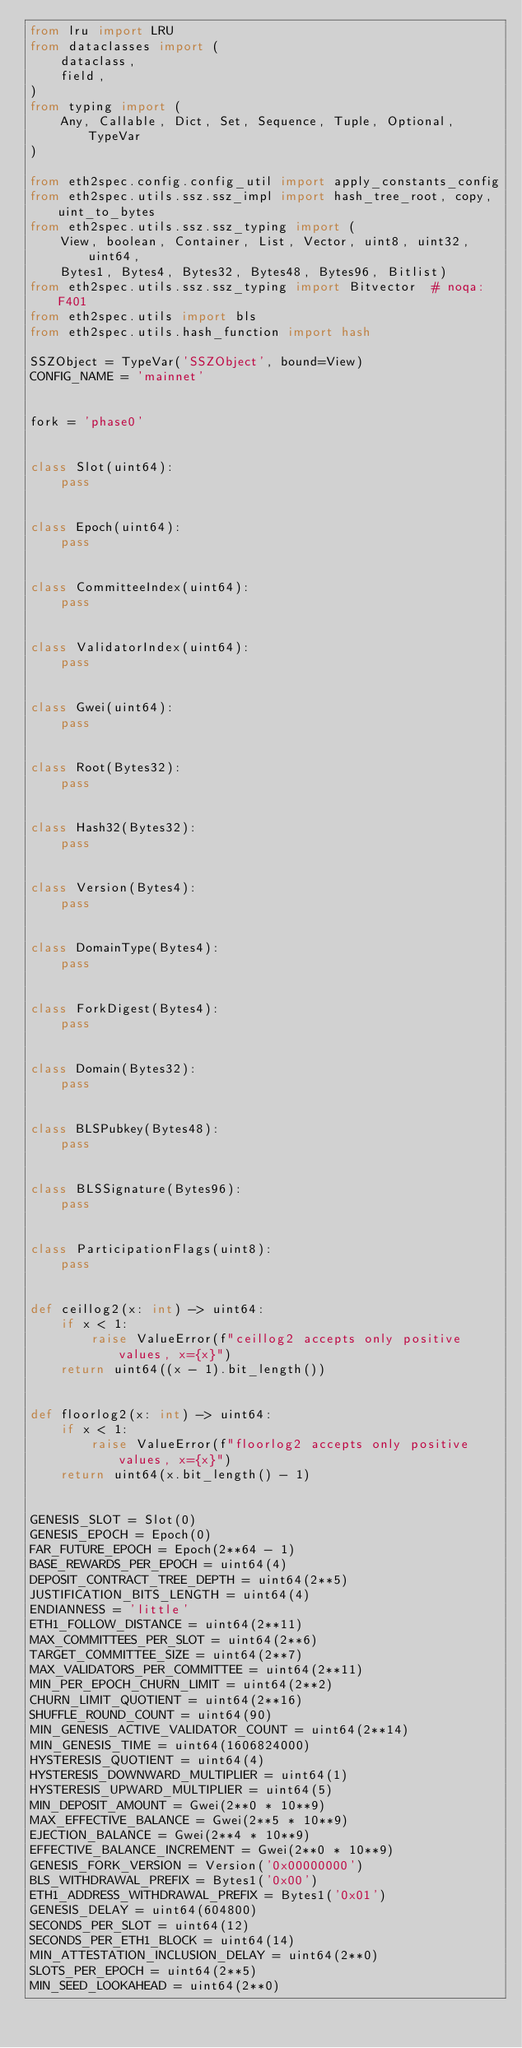Convert code to text. <code><loc_0><loc_0><loc_500><loc_500><_Python_>from lru import LRU
from dataclasses import (
    dataclass,
    field,
)
from typing import (
    Any, Callable, Dict, Set, Sequence, Tuple, Optional, TypeVar
)

from eth2spec.config.config_util import apply_constants_config
from eth2spec.utils.ssz.ssz_impl import hash_tree_root, copy, uint_to_bytes
from eth2spec.utils.ssz.ssz_typing import (
    View, boolean, Container, List, Vector, uint8, uint32, uint64,
    Bytes1, Bytes4, Bytes32, Bytes48, Bytes96, Bitlist)
from eth2spec.utils.ssz.ssz_typing import Bitvector  # noqa: F401
from eth2spec.utils import bls
from eth2spec.utils.hash_function import hash

SSZObject = TypeVar('SSZObject', bound=View)
CONFIG_NAME = 'mainnet'


fork = 'phase0'


class Slot(uint64):
    pass


class Epoch(uint64):
    pass


class CommitteeIndex(uint64):
    pass


class ValidatorIndex(uint64):
    pass


class Gwei(uint64):
    pass


class Root(Bytes32):
    pass


class Hash32(Bytes32):
    pass


class Version(Bytes4):
    pass


class DomainType(Bytes4):
    pass


class ForkDigest(Bytes4):
    pass


class Domain(Bytes32):
    pass


class BLSPubkey(Bytes48):
    pass


class BLSSignature(Bytes96):
    pass


class ParticipationFlags(uint8):
    pass


def ceillog2(x: int) -> uint64:
    if x < 1:
        raise ValueError(f"ceillog2 accepts only positive values, x={x}")
    return uint64((x - 1).bit_length())


def floorlog2(x: int) -> uint64:
    if x < 1:
        raise ValueError(f"floorlog2 accepts only positive values, x={x}")
    return uint64(x.bit_length() - 1)


GENESIS_SLOT = Slot(0)
GENESIS_EPOCH = Epoch(0)
FAR_FUTURE_EPOCH = Epoch(2**64 - 1)
BASE_REWARDS_PER_EPOCH = uint64(4)
DEPOSIT_CONTRACT_TREE_DEPTH = uint64(2**5)
JUSTIFICATION_BITS_LENGTH = uint64(4)
ENDIANNESS = 'little'
ETH1_FOLLOW_DISTANCE = uint64(2**11)
MAX_COMMITTEES_PER_SLOT = uint64(2**6)
TARGET_COMMITTEE_SIZE = uint64(2**7)
MAX_VALIDATORS_PER_COMMITTEE = uint64(2**11)
MIN_PER_EPOCH_CHURN_LIMIT = uint64(2**2)
CHURN_LIMIT_QUOTIENT = uint64(2**16)
SHUFFLE_ROUND_COUNT = uint64(90)
MIN_GENESIS_ACTIVE_VALIDATOR_COUNT = uint64(2**14)
MIN_GENESIS_TIME = uint64(1606824000)
HYSTERESIS_QUOTIENT = uint64(4)
HYSTERESIS_DOWNWARD_MULTIPLIER = uint64(1)
HYSTERESIS_UPWARD_MULTIPLIER = uint64(5)
MIN_DEPOSIT_AMOUNT = Gwei(2**0 * 10**9)
MAX_EFFECTIVE_BALANCE = Gwei(2**5 * 10**9)
EJECTION_BALANCE = Gwei(2**4 * 10**9)
EFFECTIVE_BALANCE_INCREMENT = Gwei(2**0 * 10**9)
GENESIS_FORK_VERSION = Version('0x00000000')
BLS_WITHDRAWAL_PREFIX = Bytes1('0x00')
ETH1_ADDRESS_WITHDRAWAL_PREFIX = Bytes1('0x01')
GENESIS_DELAY = uint64(604800)
SECONDS_PER_SLOT = uint64(12)
SECONDS_PER_ETH1_BLOCK = uint64(14)
MIN_ATTESTATION_INCLUSION_DELAY = uint64(2**0)
SLOTS_PER_EPOCH = uint64(2**5)
MIN_SEED_LOOKAHEAD = uint64(2**0)</code> 